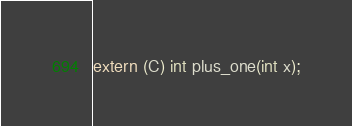Convert code to text. <code><loc_0><loc_0><loc_500><loc_500><_D_>extern (C) int plus_one(int x);
</code> 